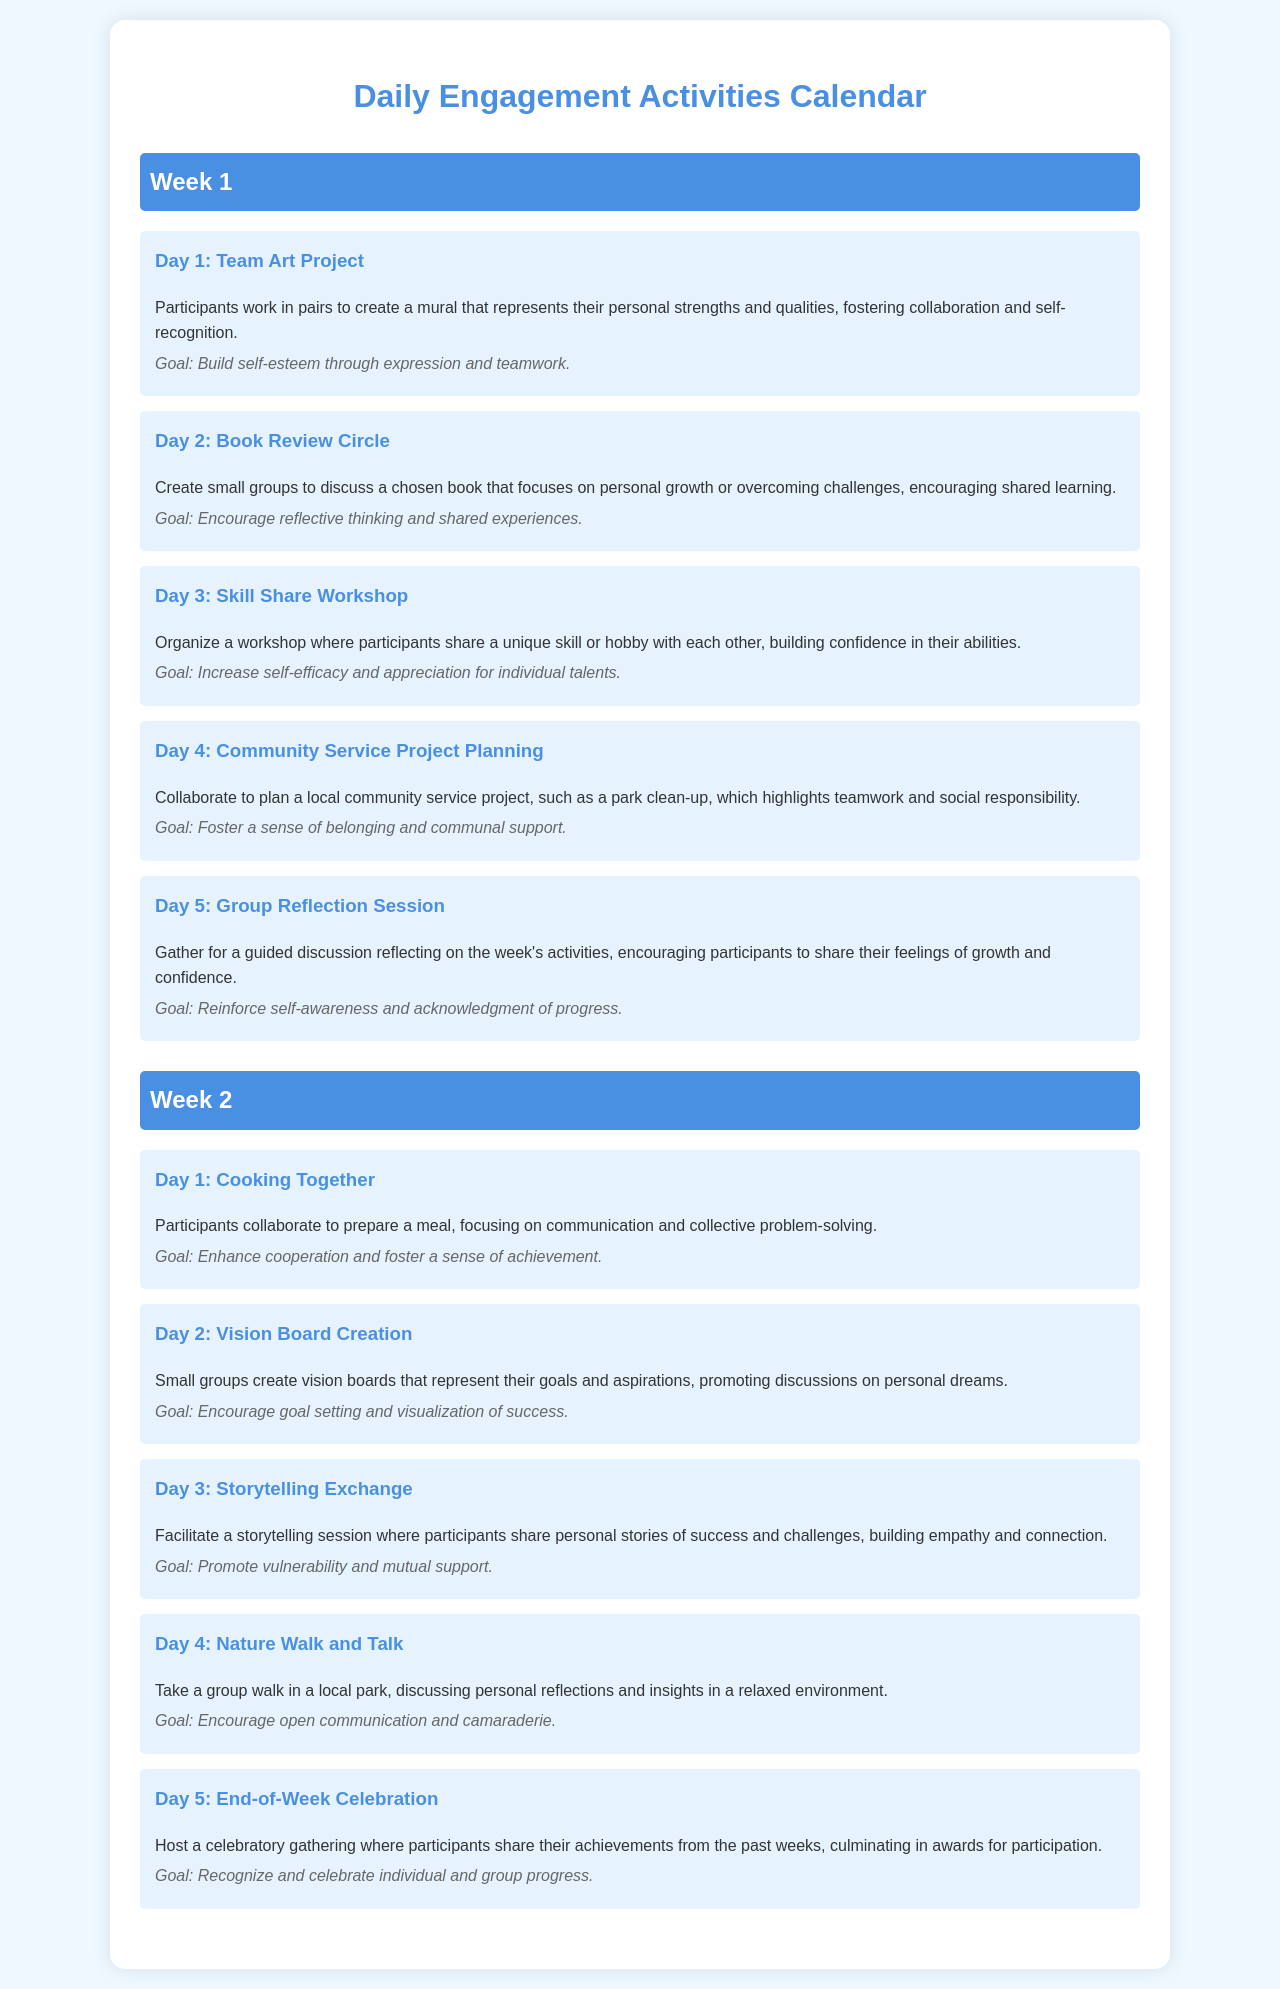What is the title of the document? The title is presented prominently at the top of the document, indicating its purpose.
Answer: Daily Engagement Activities Calendar How many days are included in Week 1? Each week in the document has a specific number of activities outlined.
Answer: 5 What is the goal of the Day 3 activity in Week 1? The goal is provided for each day's activity, summarizing its aim related to self-esteem.
Answer: Increase self-efficacy and appreciation for individual talents What type of project is planned for Day 4 in Week 1? The activity description indicates the nature of the project and its focus on community.
Answer: Community service project What is the theme of the Week 2 activities? By examining the activities, a common thread or theme can be identified.
Answer: Collaboration How many activities focus on communication in Week 2? The activities in Week 2 can be evaluated based on their emphasis on communication skills.
Answer: 3 What is the main focus of the Day 5 activity in Week 2? The activity for Day 5 summarizes the goal of recognition and celebration.
Answer: Celebrate individual and group progress What collaborative skill is practiced during the cooking activity? The description highlights the skills emphasized during the cooking activity.
Answer: Communication Which day has an activity involving personal stories? The document details the specific day dedicated to sharing experiences.
Answer: Day 3 